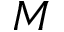<formula> <loc_0><loc_0><loc_500><loc_500>M</formula> 